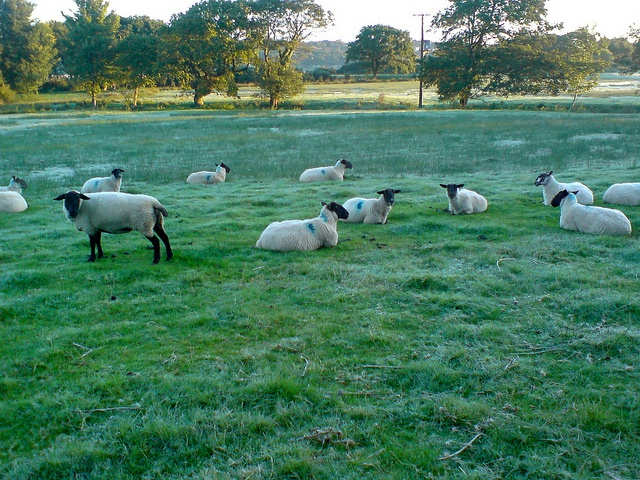Describe the objects in this image and their specific colors. I can see sheep in teal and black tones, sheep in teal, darkgray, gray, and lightblue tones, sheep in teal, gray, and darkgray tones, sheep in teal, gray, black, and lightblue tones, and sheep in teal, darkgray, gray, and black tones in this image. 